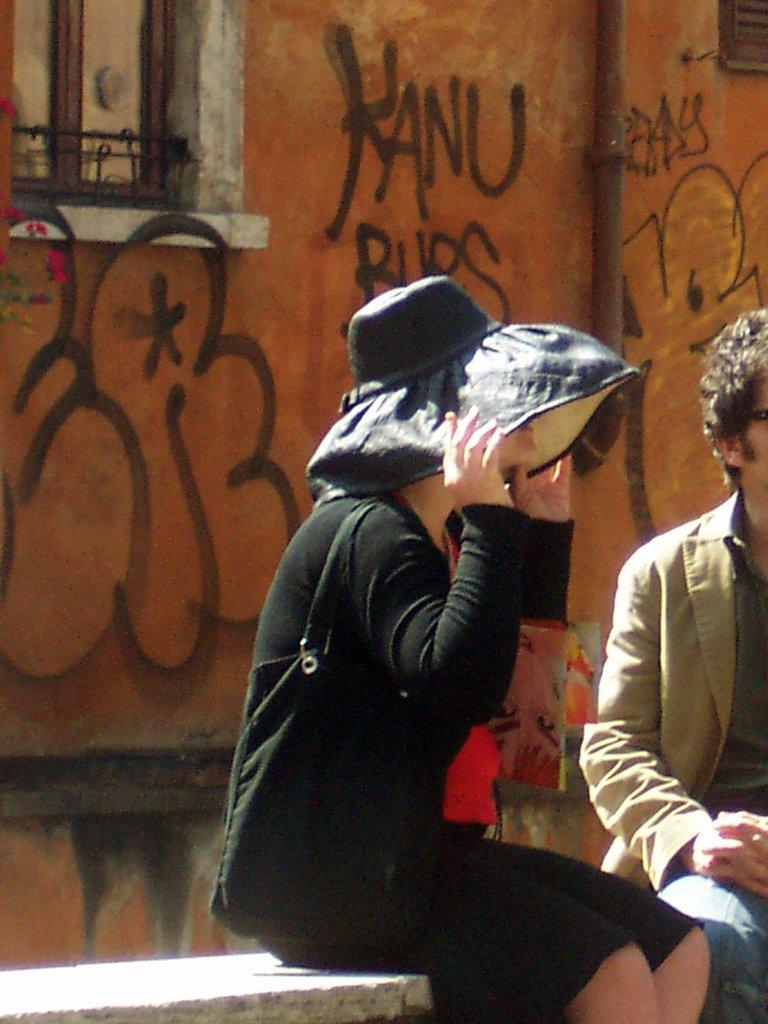Provide a one-sentence caption for the provided image. A woman wearing a black hat sits on a bench behind a will with Kanu written on it. 